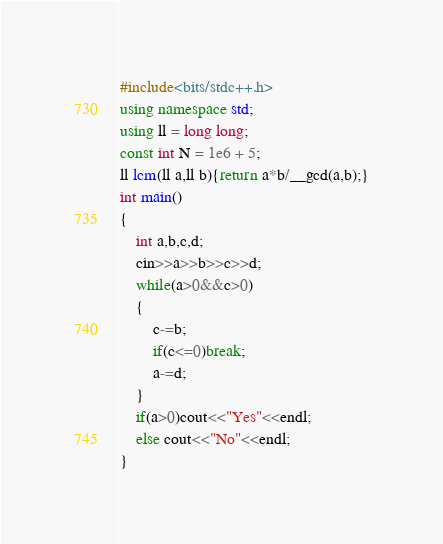Convert code to text. <code><loc_0><loc_0><loc_500><loc_500><_C++_>#include<bits/stdc++.h>
using namespace std;
using ll = long long;
const int N = 1e6 + 5;
ll lcm(ll a,ll b){return a*b/__gcd(a,b);}
int main()
{
    int a,b,c,d;
    cin>>a>>b>>c>>d;
    while(a>0&&c>0)
    {
        c-=b;
        if(c<=0)break;
        a-=d;
    }
    if(a>0)cout<<"Yes"<<endl;
    else cout<<"No"<<endl;
}
</code> 